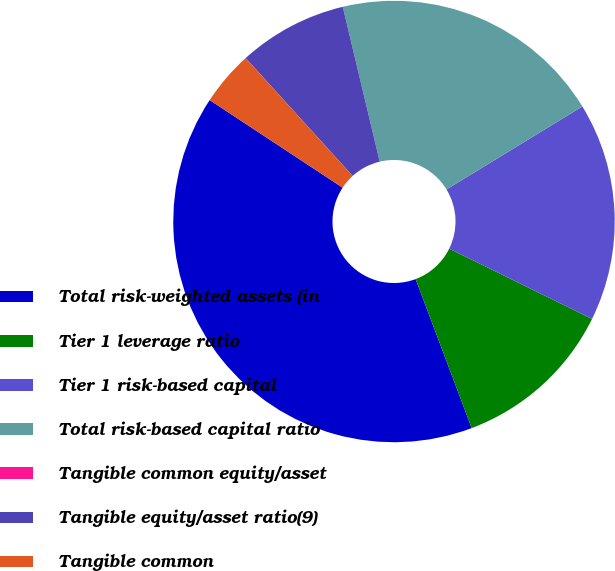<chart> <loc_0><loc_0><loc_500><loc_500><pie_chart><fcel>Total risk-weighted assets (in<fcel>Tier 1 leverage ratio<fcel>Tier 1 risk-based capital<fcel>Total risk-based capital ratio<fcel>Tangible common equity/asset<fcel>Tangible equity/asset ratio(9)<fcel>Tangible common<nl><fcel>39.99%<fcel>12.0%<fcel>16.0%<fcel>20.0%<fcel>0.0%<fcel>8.0%<fcel>4.0%<nl></chart> 